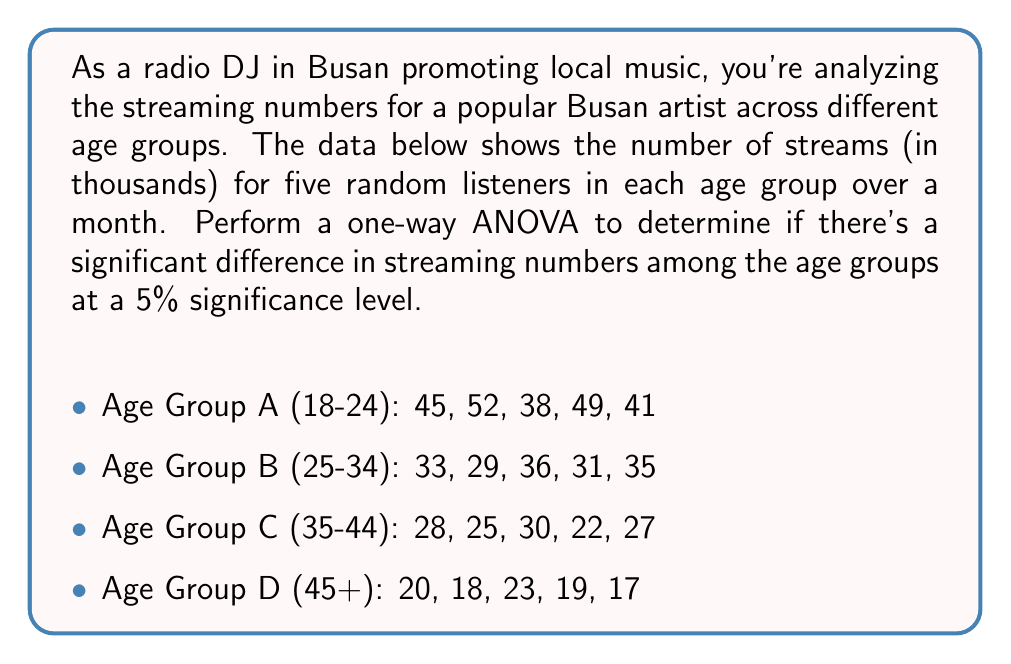Help me with this question. To perform a one-way ANOVA, we'll follow these steps:

1. Calculate the sum of squares between groups (SSB) and within groups (SSW).
2. Calculate the degrees of freedom for between groups (dfB) and within groups (dfW).
3. Calculate the mean squares for between groups (MSB) and within groups (MSW).
4. Calculate the F-statistic.
5. Compare the F-statistic to the critical F-value.

Step 1: Calculate SSB and SSW

First, we need to calculate the grand mean and group means:

Grand mean: $\bar{X} = \frac{593}{20} = 29.65$

Group means:
A: $\bar{X}_A = 45$
B: $\bar{X}_B = 32.8$
C: $\bar{X}_C = 26.4$
D: $\bar{X}_D = 19.4$

Now, we can calculate SSB and SSW:

$$SSB = \sum_{i=1}^k n_i(\bar{X}_i - \bar{X})^2$$
$$SSB = 5(45 - 29.65)^2 + 5(32.8 - 29.65)^2 + 5(26.4 - 29.65)^2 + 5(19.4 - 29.65)^2 = 2046.55$$

$$SSW = \sum_{i=1}^k\sum_{j=1}^{n_i} (X_{ij} - \bar{X}_i)^2$$
$$SSW = 134 + 38 + 40 + 30 = 242$$

Step 2: Calculate degrees of freedom

$$df_B = k - 1 = 4 - 1 = 3$$
$$df_W = N - k = 20 - 4 = 16$$

Step 3: Calculate mean squares

$$MSB = \frac{SSB}{df_B} = \frac{2046.55}{3} = 682.18$$
$$MSW = \frac{SSW}{df_W} = \frac{242}{16} = 15.13$$

Step 4: Calculate F-statistic

$$F = \frac{MSB}{MSW} = \frac{682.18}{15.13} = 45.09$$

Step 5: Compare F-statistic to critical F-value

The critical F-value for $\alpha = 0.05$, $df_B = 3$, and $df_W = 16$ is approximately 3.24.

Since our calculated F-statistic (45.09) is greater than the critical F-value (3.24), we reject the null hypothesis.
Answer: The one-way ANOVA results show a significant difference in streaming numbers among the age groups (F(3, 16) = 45.09, p < 0.05). We reject the null hypothesis and conclude that there are statistically significant differences in streaming numbers between at least two age groups. 